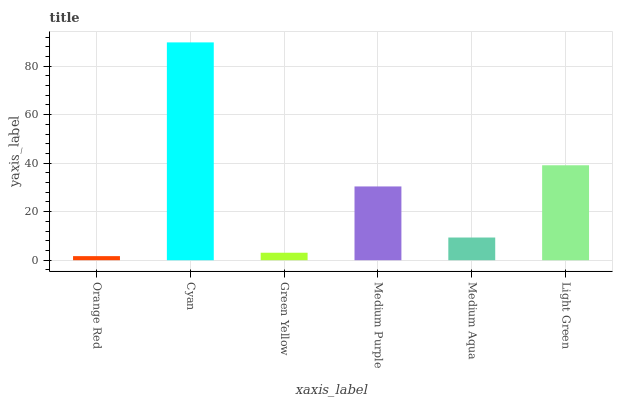Is Orange Red the minimum?
Answer yes or no. Yes. Is Cyan the maximum?
Answer yes or no. Yes. Is Green Yellow the minimum?
Answer yes or no. No. Is Green Yellow the maximum?
Answer yes or no. No. Is Cyan greater than Green Yellow?
Answer yes or no. Yes. Is Green Yellow less than Cyan?
Answer yes or no. Yes. Is Green Yellow greater than Cyan?
Answer yes or no. No. Is Cyan less than Green Yellow?
Answer yes or no. No. Is Medium Purple the high median?
Answer yes or no. Yes. Is Medium Aqua the low median?
Answer yes or no. Yes. Is Orange Red the high median?
Answer yes or no. No. Is Green Yellow the low median?
Answer yes or no. No. 